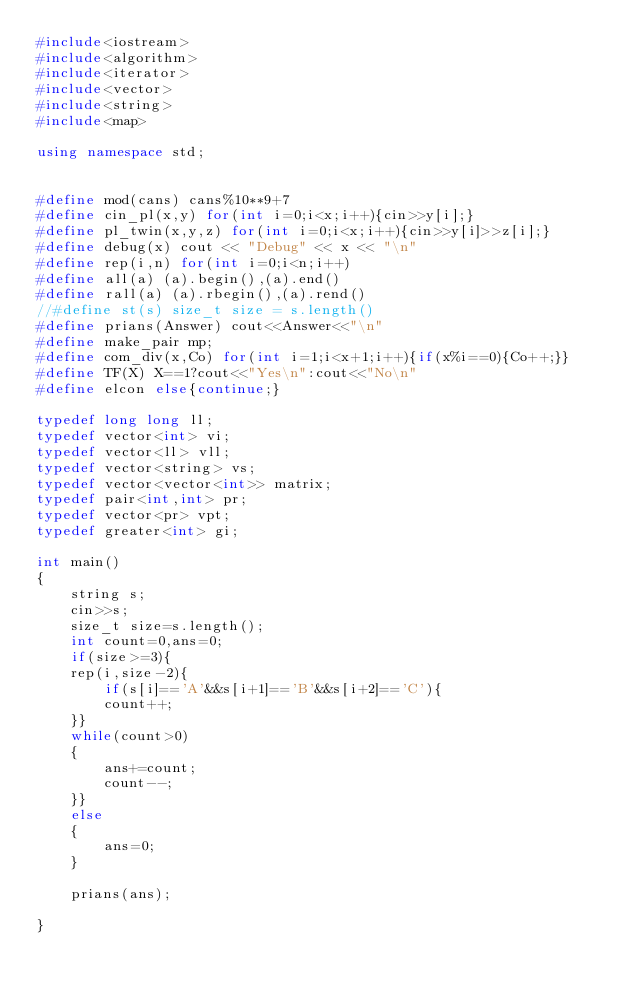Convert code to text. <code><loc_0><loc_0><loc_500><loc_500><_C++_>#include<iostream>
#include<algorithm>
#include<iterator>
#include<vector>
#include<string>
#include<map>

using namespace std;


#define mod(cans) cans%10**9+7
#define cin_pl(x,y) for(int i=0;i<x;i++){cin>>y[i];}
#define pl_twin(x,y,z) for(int i=0;i<x;i++){cin>>y[i]>>z[i];}
#define debug(x) cout << "Debug" << x << "\n"
#define rep(i,n) for(int i=0;i<n;i++)
#define all(a) (a).begin(),(a).end()
#define rall(a) (a).rbegin(),(a).rend()
//#define st(s) size_t size = s.length()
#define prians(Answer) cout<<Answer<<"\n"
#define make_pair mp;
#define com_div(x,Co) for(int i=1;i<x+1;i++){if(x%i==0){Co++;}}
#define TF(X) X==1?cout<<"Yes\n":cout<<"No\n"
#define elcon else{continue;}

typedef long long ll;
typedef vector<int> vi;
typedef vector<ll> vll;
typedef vector<string> vs;
typedef vector<vector<int>> matrix;
typedef pair<int,int> pr;
typedef vector<pr> vpt;
typedef greater<int> gi;

int main()
{
    string s;
    cin>>s;
    size_t size=s.length();
    int count=0,ans=0;
    if(size>=3){
    rep(i,size-2){
        if(s[i]=='A'&&s[i+1]=='B'&&s[i+2]=='C'){
        count++;
    }}
    while(count>0)
    {
        ans+=count;
        count--;
    }}
    else
    {
        ans=0;
    }
    
    prians(ans);
    
}</code> 